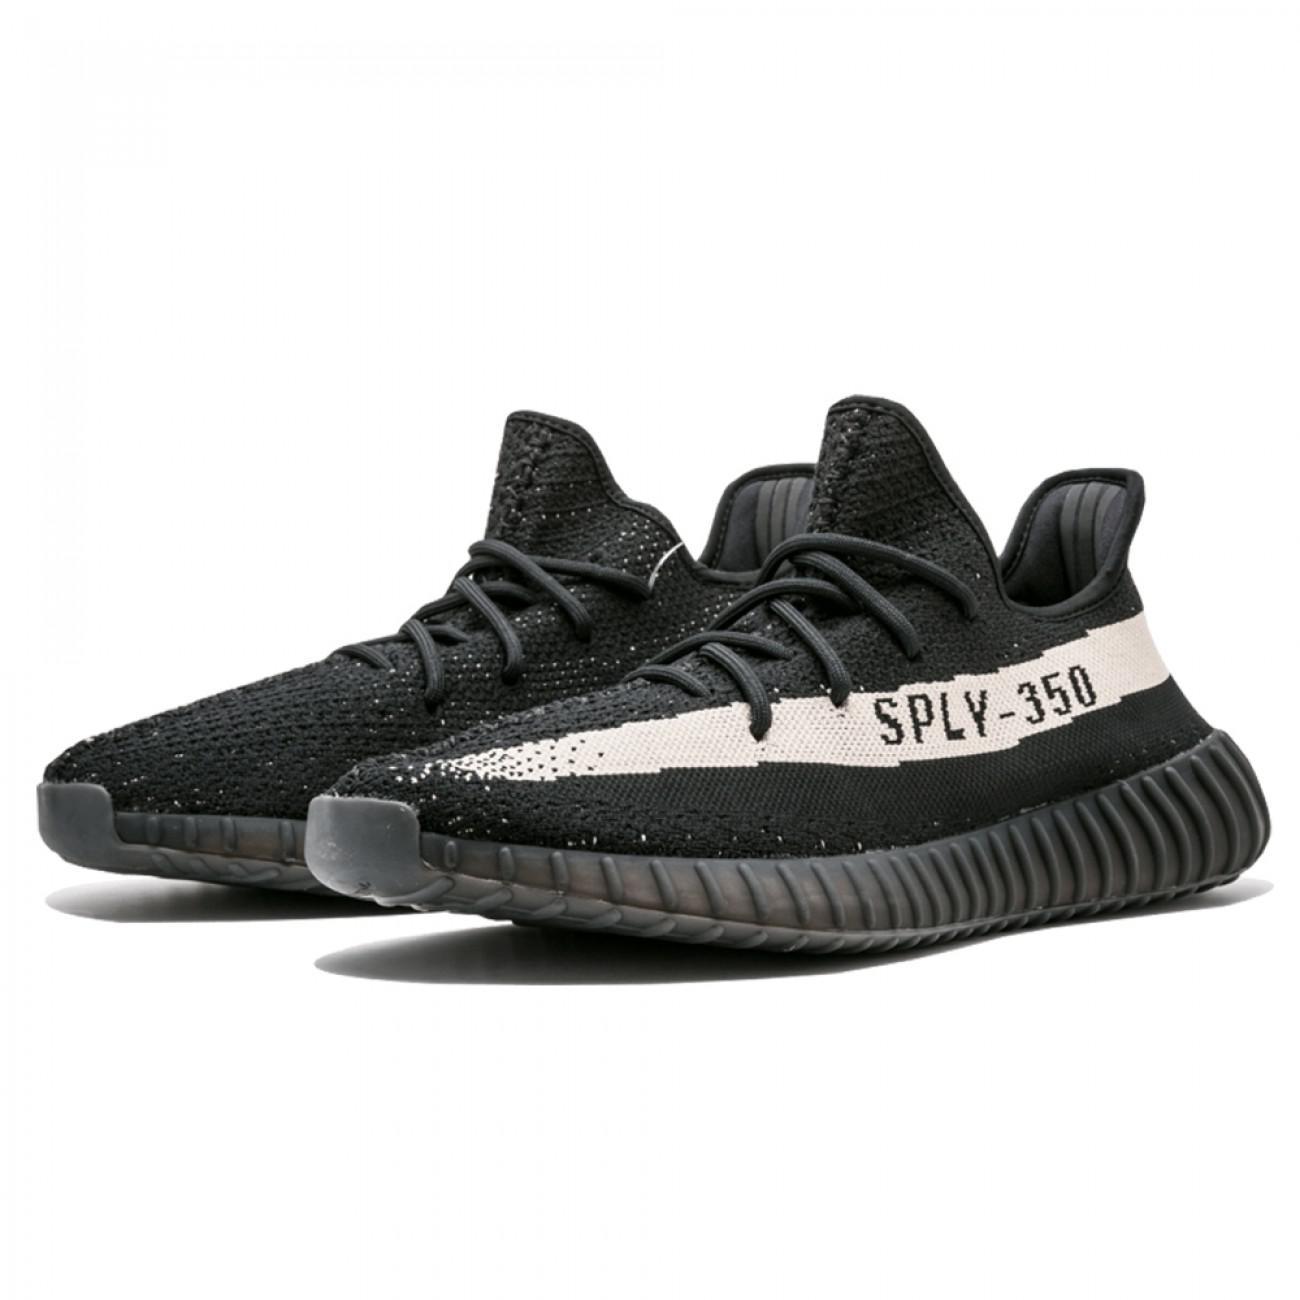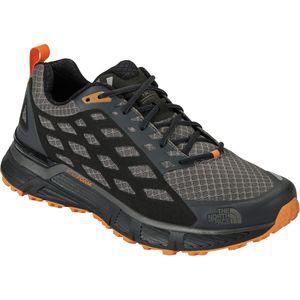The first image is the image on the left, the second image is the image on the right. Given the left and right images, does the statement "Left and right images each contain a single shoe with an athletic tread sole, one shoe has a zig-zag design element, and the shoe on the right has a loop at the heel." hold true? Answer yes or no. No. The first image is the image on the left, the second image is the image on the right. Considering the images on both sides, is "The toes of all the shoes point to the right side." valid? Answer yes or no. No. 